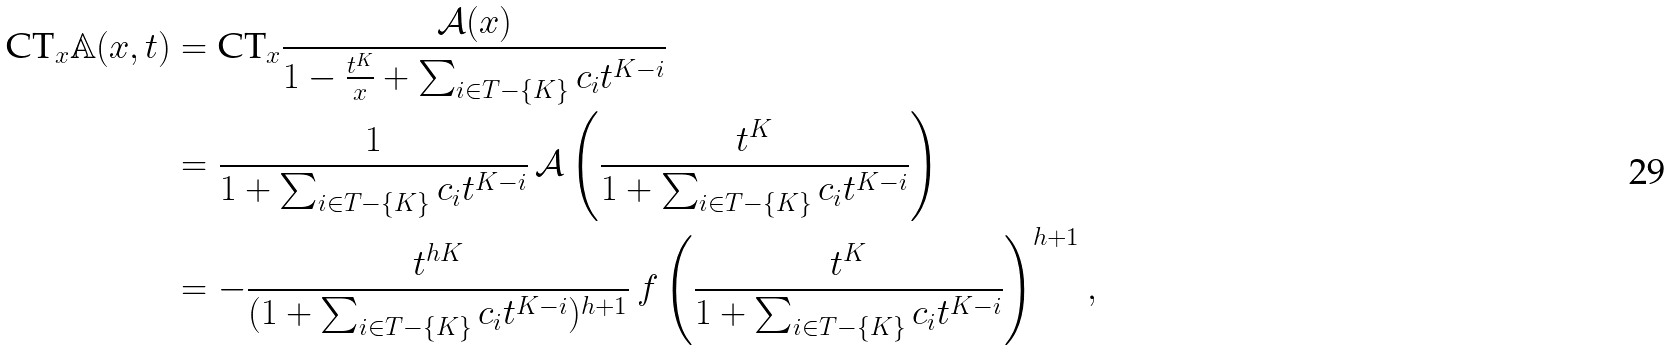<formula> <loc_0><loc_0><loc_500><loc_500>\text {CT} _ { x } \mathbb { A } ( x , t ) & = \text {CT} _ { x } \frac { \mathcal { A } ( x ) } { 1 - \frac { t ^ { K } } { x } + \sum _ { i \in T - \{ K \} } c _ { i } t ^ { K - i } } \\ & = \frac { 1 } { 1 + \sum _ { i \in T - \{ K \} } c _ { i } t ^ { K - i } } \, \mathcal { A } \left ( \frac { t ^ { K } } { 1 + \sum _ { i \in T - \{ K \} } c _ { i } t ^ { K - i } } \right ) \\ & = - \frac { t ^ { h K } } { ( 1 + \sum _ { i \in T - \{ K \} } c _ { i } t ^ { K - i } ) ^ { h + 1 } } \, f \left ( \frac { t ^ { K } } { 1 + \sum _ { i \in T - \{ K \} } c _ { i } t ^ { K - i } } \right ) ^ { h + 1 } ,</formula> 